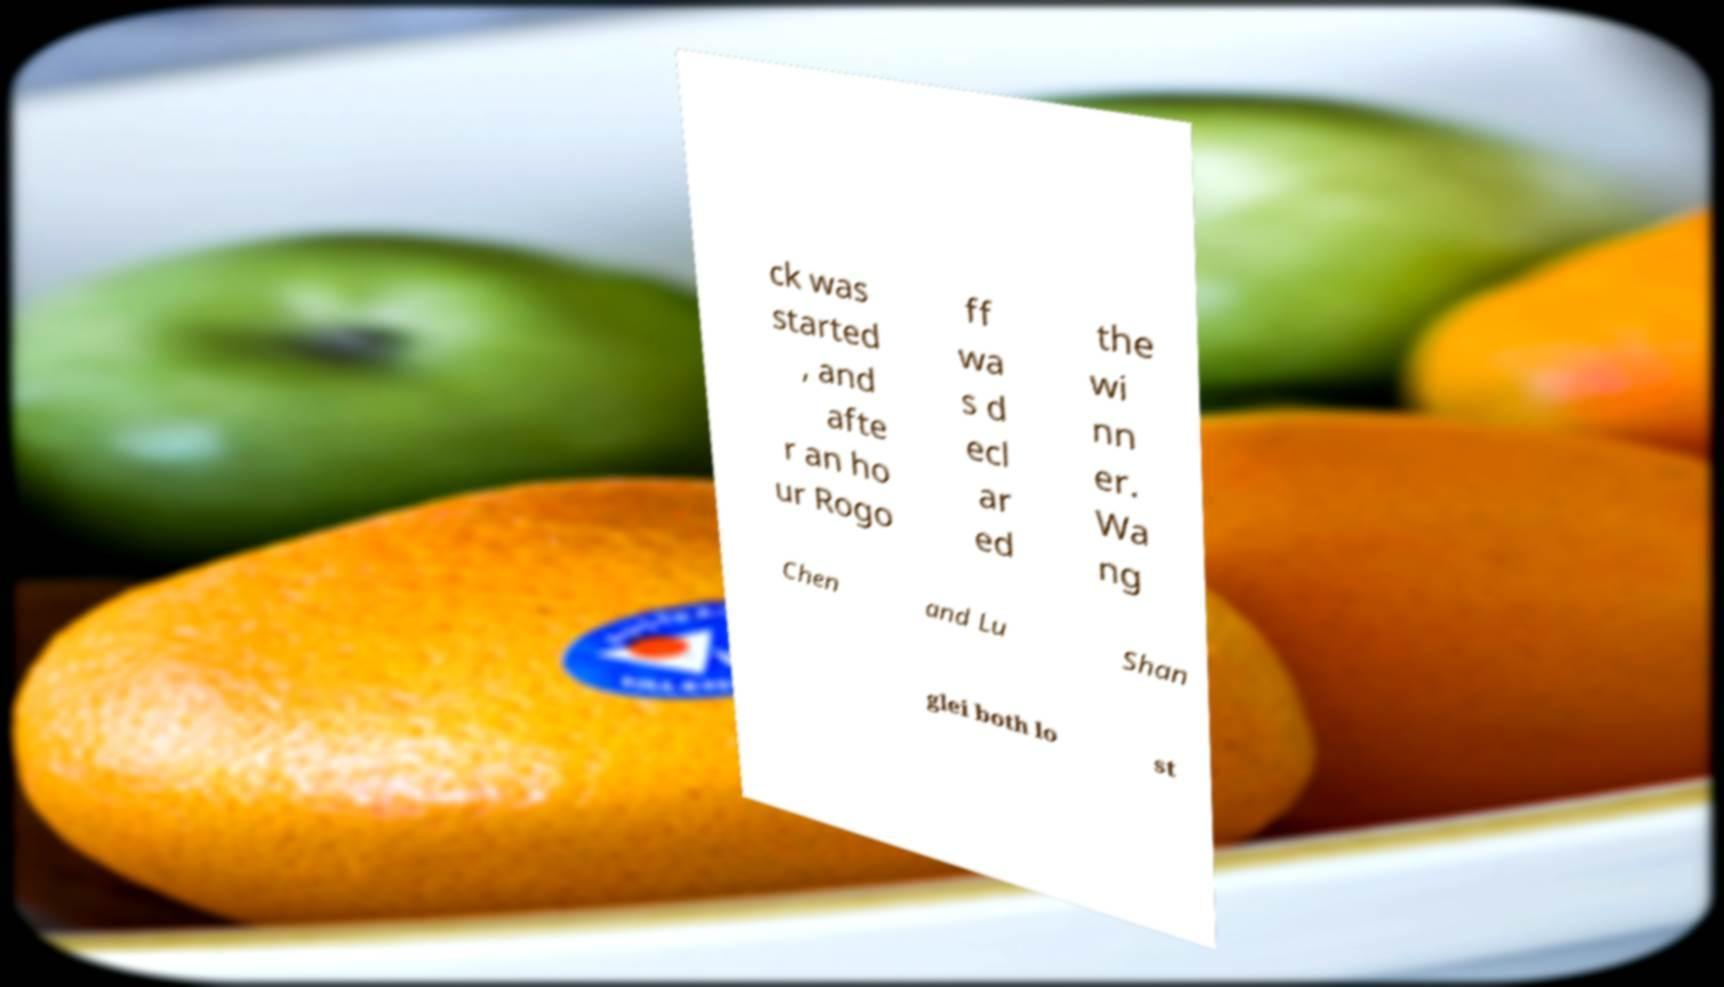Can you read and provide the text displayed in the image?This photo seems to have some interesting text. Can you extract and type it out for me? ck was started , and afte r an ho ur Rogo ff wa s d ecl ar ed the wi nn er. Wa ng Chen and Lu Shan glei both lo st 